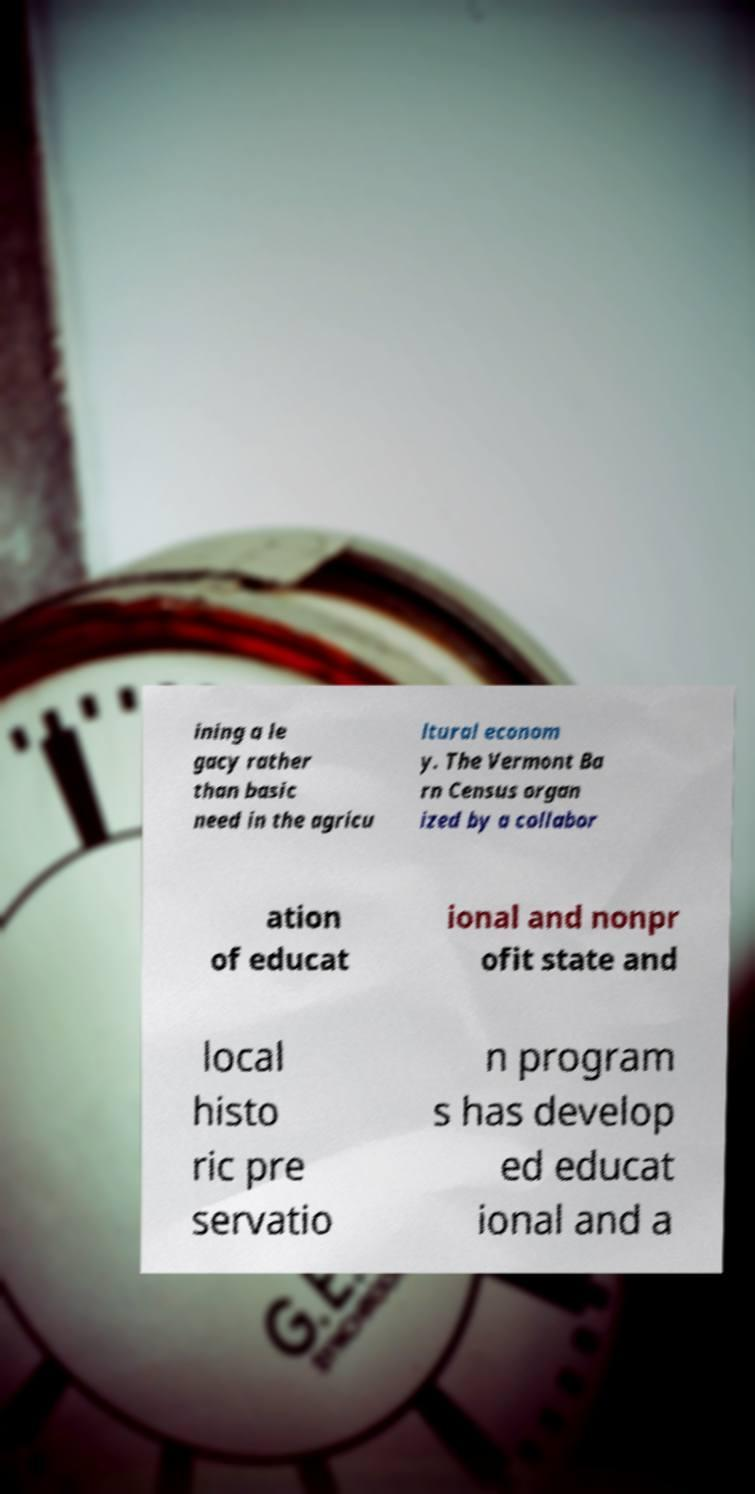Can you read and provide the text displayed in the image?This photo seems to have some interesting text. Can you extract and type it out for me? ining a le gacy rather than basic need in the agricu ltural econom y. The Vermont Ba rn Census organ ized by a collabor ation of educat ional and nonpr ofit state and local histo ric pre servatio n program s has develop ed educat ional and a 